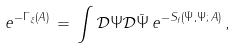<formula> <loc_0><loc_0><loc_500><loc_500>e ^ { - \Gamma _ { \xi } ( A ) } \, = \, \int { \mathcal { D } } \Psi { \mathcal { D } } { \bar { \Psi } } \, e ^ { - S _ { f } ( { \bar { \Psi } } , \Psi ; \, A ) } \, ,</formula> 